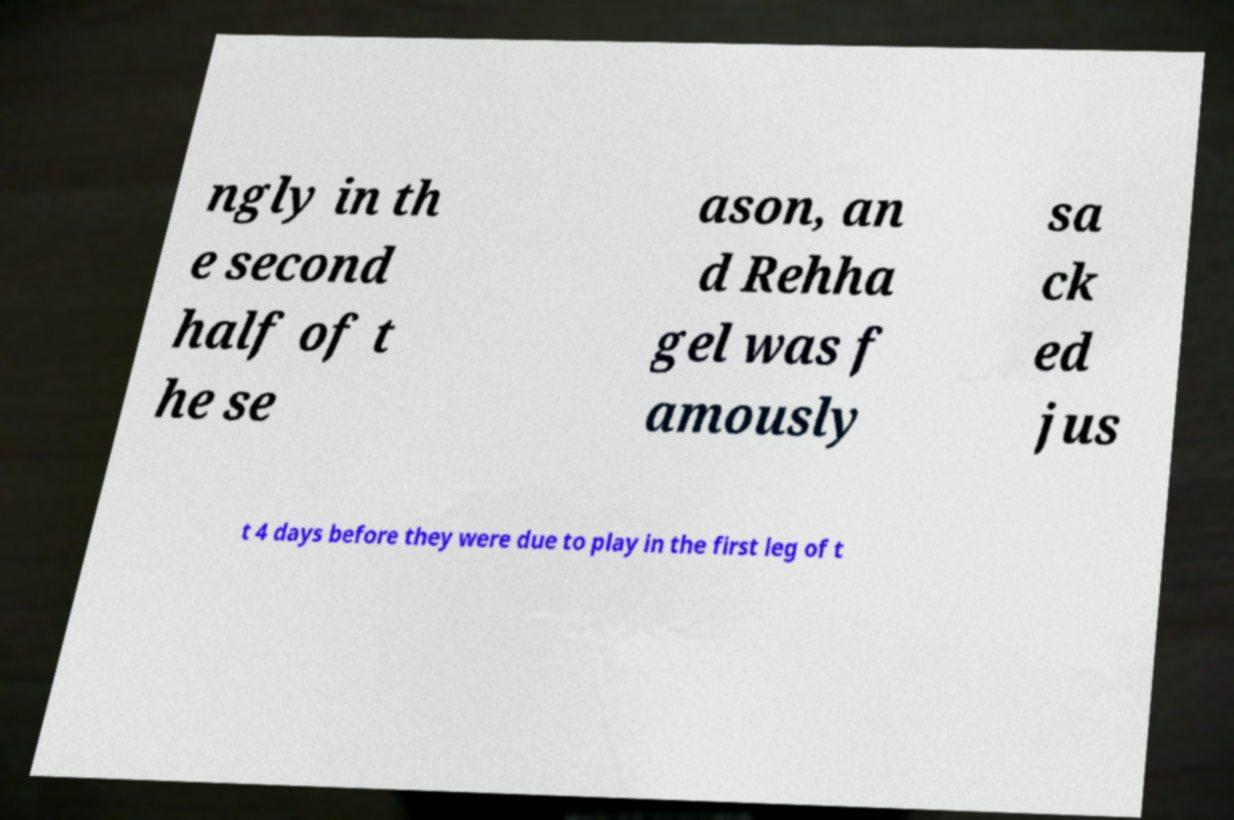Could you assist in decoding the text presented in this image and type it out clearly? ngly in th e second half of t he se ason, an d Rehha gel was f amously sa ck ed jus t 4 days before they were due to play in the first leg of t 